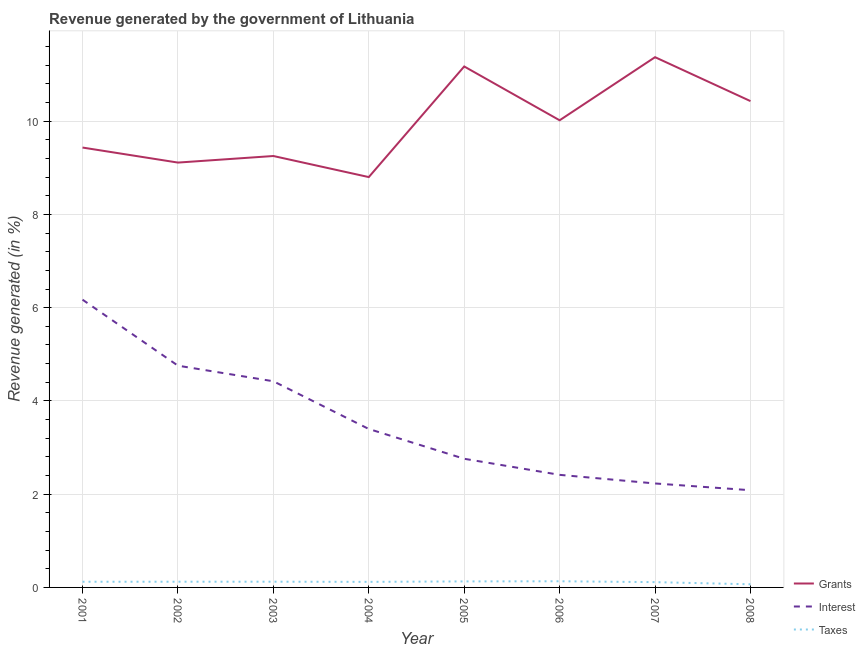Is the number of lines equal to the number of legend labels?
Give a very brief answer. Yes. What is the percentage of revenue generated by grants in 2003?
Provide a short and direct response. 9.25. Across all years, what is the maximum percentage of revenue generated by taxes?
Provide a short and direct response. 0.13. Across all years, what is the minimum percentage of revenue generated by grants?
Ensure brevity in your answer.  8.8. What is the total percentage of revenue generated by grants in the graph?
Offer a very short reply. 79.6. What is the difference between the percentage of revenue generated by grants in 2006 and that in 2008?
Offer a terse response. -0.41. What is the difference between the percentage of revenue generated by interest in 2006 and the percentage of revenue generated by taxes in 2001?
Offer a very short reply. 2.29. What is the average percentage of revenue generated by taxes per year?
Your answer should be very brief. 0.12. In the year 2002, what is the difference between the percentage of revenue generated by taxes and percentage of revenue generated by interest?
Provide a succinct answer. -4.63. What is the ratio of the percentage of revenue generated by grants in 2006 to that in 2007?
Give a very brief answer. 0.88. Is the percentage of revenue generated by taxes in 2003 less than that in 2004?
Your answer should be very brief. No. What is the difference between the highest and the second highest percentage of revenue generated by taxes?
Your response must be concise. 0. What is the difference between the highest and the lowest percentage of revenue generated by taxes?
Ensure brevity in your answer.  0.06. In how many years, is the percentage of revenue generated by grants greater than the average percentage of revenue generated by grants taken over all years?
Provide a succinct answer. 4. Is the sum of the percentage of revenue generated by grants in 2004 and 2005 greater than the maximum percentage of revenue generated by interest across all years?
Provide a short and direct response. Yes. Is it the case that in every year, the sum of the percentage of revenue generated by grants and percentage of revenue generated by interest is greater than the percentage of revenue generated by taxes?
Give a very brief answer. Yes. Is the percentage of revenue generated by interest strictly less than the percentage of revenue generated by grants over the years?
Your response must be concise. Yes. How many years are there in the graph?
Your answer should be compact. 8. What is the difference between two consecutive major ticks on the Y-axis?
Your answer should be very brief. 2. Are the values on the major ticks of Y-axis written in scientific E-notation?
Give a very brief answer. No. Does the graph contain any zero values?
Your answer should be compact. No. Where does the legend appear in the graph?
Provide a short and direct response. Bottom right. How many legend labels are there?
Give a very brief answer. 3. What is the title of the graph?
Your response must be concise. Revenue generated by the government of Lithuania. What is the label or title of the Y-axis?
Your answer should be very brief. Revenue generated (in %). What is the Revenue generated (in %) in Grants in 2001?
Ensure brevity in your answer.  9.44. What is the Revenue generated (in %) in Interest in 2001?
Ensure brevity in your answer.  6.17. What is the Revenue generated (in %) in Taxes in 2001?
Provide a succinct answer. 0.12. What is the Revenue generated (in %) in Grants in 2002?
Your response must be concise. 9.11. What is the Revenue generated (in %) of Interest in 2002?
Your answer should be compact. 4.76. What is the Revenue generated (in %) of Taxes in 2002?
Offer a terse response. 0.12. What is the Revenue generated (in %) in Grants in 2003?
Ensure brevity in your answer.  9.25. What is the Revenue generated (in %) of Interest in 2003?
Provide a short and direct response. 4.42. What is the Revenue generated (in %) of Taxes in 2003?
Your answer should be very brief. 0.12. What is the Revenue generated (in %) of Grants in 2004?
Offer a very short reply. 8.8. What is the Revenue generated (in %) of Interest in 2004?
Your answer should be compact. 3.4. What is the Revenue generated (in %) in Taxes in 2004?
Ensure brevity in your answer.  0.12. What is the Revenue generated (in %) of Grants in 2005?
Give a very brief answer. 11.17. What is the Revenue generated (in %) of Interest in 2005?
Provide a short and direct response. 2.76. What is the Revenue generated (in %) of Taxes in 2005?
Your response must be concise. 0.13. What is the Revenue generated (in %) in Grants in 2006?
Ensure brevity in your answer.  10.02. What is the Revenue generated (in %) in Interest in 2006?
Keep it short and to the point. 2.41. What is the Revenue generated (in %) of Taxes in 2006?
Offer a very short reply. 0.13. What is the Revenue generated (in %) in Grants in 2007?
Your answer should be very brief. 11.37. What is the Revenue generated (in %) of Interest in 2007?
Provide a succinct answer. 2.23. What is the Revenue generated (in %) of Taxes in 2007?
Ensure brevity in your answer.  0.11. What is the Revenue generated (in %) in Grants in 2008?
Your answer should be very brief. 10.43. What is the Revenue generated (in %) in Interest in 2008?
Give a very brief answer. 2.09. What is the Revenue generated (in %) of Taxes in 2008?
Offer a very short reply. 0.07. Across all years, what is the maximum Revenue generated (in %) in Grants?
Provide a short and direct response. 11.37. Across all years, what is the maximum Revenue generated (in %) of Interest?
Keep it short and to the point. 6.17. Across all years, what is the maximum Revenue generated (in %) in Taxes?
Provide a succinct answer. 0.13. Across all years, what is the minimum Revenue generated (in %) of Grants?
Offer a very short reply. 8.8. Across all years, what is the minimum Revenue generated (in %) in Interest?
Keep it short and to the point. 2.09. Across all years, what is the minimum Revenue generated (in %) of Taxes?
Give a very brief answer. 0.07. What is the total Revenue generated (in %) in Grants in the graph?
Provide a short and direct response. 79.6. What is the total Revenue generated (in %) in Interest in the graph?
Your answer should be compact. 28.24. What is the total Revenue generated (in %) in Taxes in the graph?
Your response must be concise. 0.93. What is the difference between the Revenue generated (in %) in Grants in 2001 and that in 2002?
Offer a very short reply. 0.32. What is the difference between the Revenue generated (in %) of Interest in 2001 and that in 2002?
Offer a very short reply. 1.42. What is the difference between the Revenue generated (in %) of Taxes in 2001 and that in 2002?
Your answer should be very brief. -0. What is the difference between the Revenue generated (in %) of Grants in 2001 and that in 2003?
Offer a terse response. 0.18. What is the difference between the Revenue generated (in %) in Interest in 2001 and that in 2003?
Provide a short and direct response. 1.75. What is the difference between the Revenue generated (in %) in Taxes in 2001 and that in 2003?
Your answer should be very brief. -0. What is the difference between the Revenue generated (in %) in Grants in 2001 and that in 2004?
Provide a succinct answer. 0.63. What is the difference between the Revenue generated (in %) of Interest in 2001 and that in 2004?
Offer a terse response. 2.77. What is the difference between the Revenue generated (in %) of Taxes in 2001 and that in 2004?
Offer a very short reply. 0. What is the difference between the Revenue generated (in %) of Grants in 2001 and that in 2005?
Keep it short and to the point. -1.74. What is the difference between the Revenue generated (in %) in Interest in 2001 and that in 2005?
Your response must be concise. 3.41. What is the difference between the Revenue generated (in %) of Taxes in 2001 and that in 2005?
Make the answer very short. -0.01. What is the difference between the Revenue generated (in %) in Grants in 2001 and that in 2006?
Your response must be concise. -0.58. What is the difference between the Revenue generated (in %) in Interest in 2001 and that in 2006?
Offer a very short reply. 3.76. What is the difference between the Revenue generated (in %) of Taxes in 2001 and that in 2006?
Your response must be concise. -0.01. What is the difference between the Revenue generated (in %) of Grants in 2001 and that in 2007?
Provide a succinct answer. -1.94. What is the difference between the Revenue generated (in %) of Interest in 2001 and that in 2007?
Keep it short and to the point. 3.94. What is the difference between the Revenue generated (in %) in Taxes in 2001 and that in 2007?
Keep it short and to the point. 0.01. What is the difference between the Revenue generated (in %) of Grants in 2001 and that in 2008?
Make the answer very short. -1. What is the difference between the Revenue generated (in %) of Interest in 2001 and that in 2008?
Make the answer very short. 4.09. What is the difference between the Revenue generated (in %) of Taxes in 2001 and that in 2008?
Keep it short and to the point. 0.05. What is the difference between the Revenue generated (in %) in Grants in 2002 and that in 2003?
Provide a short and direct response. -0.14. What is the difference between the Revenue generated (in %) in Interest in 2002 and that in 2003?
Make the answer very short. 0.33. What is the difference between the Revenue generated (in %) of Taxes in 2002 and that in 2003?
Provide a short and direct response. -0. What is the difference between the Revenue generated (in %) in Grants in 2002 and that in 2004?
Your response must be concise. 0.31. What is the difference between the Revenue generated (in %) in Interest in 2002 and that in 2004?
Your response must be concise. 1.36. What is the difference between the Revenue generated (in %) of Taxes in 2002 and that in 2004?
Your answer should be very brief. 0. What is the difference between the Revenue generated (in %) of Grants in 2002 and that in 2005?
Your answer should be compact. -2.06. What is the difference between the Revenue generated (in %) of Interest in 2002 and that in 2005?
Make the answer very short. 2. What is the difference between the Revenue generated (in %) of Taxes in 2002 and that in 2005?
Ensure brevity in your answer.  -0.01. What is the difference between the Revenue generated (in %) in Grants in 2002 and that in 2006?
Your response must be concise. -0.91. What is the difference between the Revenue generated (in %) in Interest in 2002 and that in 2006?
Provide a short and direct response. 2.34. What is the difference between the Revenue generated (in %) of Taxes in 2002 and that in 2006?
Your answer should be very brief. -0.01. What is the difference between the Revenue generated (in %) of Grants in 2002 and that in 2007?
Your answer should be very brief. -2.26. What is the difference between the Revenue generated (in %) of Interest in 2002 and that in 2007?
Offer a terse response. 2.53. What is the difference between the Revenue generated (in %) in Taxes in 2002 and that in 2007?
Keep it short and to the point. 0.01. What is the difference between the Revenue generated (in %) of Grants in 2002 and that in 2008?
Your answer should be very brief. -1.32. What is the difference between the Revenue generated (in %) in Interest in 2002 and that in 2008?
Keep it short and to the point. 2.67. What is the difference between the Revenue generated (in %) of Taxes in 2002 and that in 2008?
Offer a terse response. 0.06. What is the difference between the Revenue generated (in %) of Grants in 2003 and that in 2004?
Provide a succinct answer. 0.45. What is the difference between the Revenue generated (in %) in Interest in 2003 and that in 2004?
Your response must be concise. 1.02. What is the difference between the Revenue generated (in %) of Taxes in 2003 and that in 2004?
Make the answer very short. 0. What is the difference between the Revenue generated (in %) in Grants in 2003 and that in 2005?
Offer a terse response. -1.92. What is the difference between the Revenue generated (in %) of Interest in 2003 and that in 2005?
Your response must be concise. 1.66. What is the difference between the Revenue generated (in %) in Taxes in 2003 and that in 2005?
Offer a very short reply. -0.01. What is the difference between the Revenue generated (in %) of Grants in 2003 and that in 2006?
Keep it short and to the point. -0.77. What is the difference between the Revenue generated (in %) of Interest in 2003 and that in 2006?
Offer a very short reply. 2.01. What is the difference between the Revenue generated (in %) in Taxes in 2003 and that in 2006?
Your answer should be compact. -0.01. What is the difference between the Revenue generated (in %) in Grants in 2003 and that in 2007?
Provide a short and direct response. -2.12. What is the difference between the Revenue generated (in %) in Interest in 2003 and that in 2007?
Provide a short and direct response. 2.19. What is the difference between the Revenue generated (in %) of Taxes in 2003 and that in 2007?
Provide a succinct answer. 0.01. What is the difference between the Revenue generated (in %) in Grants in 2003 and that in 2008?
Offer a very short reply. -1.18. What is the difference between the Revenue generated (in %) in Interest in 2003 and that in 2008?
Give a very brief answer. 2.34. What is the difference between the Revenue generated (in %) in Taxes in 2003 and that in 2008?
Offer a terse response. 0.06. What is the difference between the Revenue generated (in %) in Grants in 2004 and that in 2005?
Ensure brevity in your answer.  -2.37. What is the difference between the Revenue generated (in %) in Interest in 2004 and that in 2005?
Provide a short and direct response. 0.64. What is the difference between the Revenue generated (in %) of Taxes in 2004 and that in 2005?
Offer a very short reply. -0.01. What is the difference between the Revenue generated (in %) in Grants in 2004 and that in 2006?
Provide a succinct answer. -1.22. What is the difference between the Revenue generated (in %) in Interest in 2004 and that in 2006?
Your answer should be very brief. 0.98. What is the difference between the Revenue generated (in %) of Taxes in 2004 and that in 2006?
Your answer should be very brief. -0.01. What is the difference between the Revenue generated (in %) in Grants in 2004 and that in 2007?
Offer a very short reply. -2.57. What is the difference between the Revenue generated (in %) in Interest in 2004 and that in 2007?
Provide a short and direct response. 1.17. What is the difference between the Revenue generated (in %) in Taxes in 2004 and that in 2007?
Give a very brief answer. 0.01. What is the difference between the Revenue generated (in %) in Grants in 2004 and that in 2008?
Your response must be concise. -1.63. What is the difference between the Revenue generated (in %) of Interest in 2004 and that in 2008?
Provide a succinct answer. 1.31. What is the difference between the Revenue generated (in %) of Taxes in 2004 and that in 2008?
Your response must be concise. 0.05. What is the difference between the Revenue generated (in %) in Grants in 2005 and that in 2006?
Give a very brief answer. 1.15. What is the difference between the Revenue generated (in %) in Interest in 2005 and that in 2006?
Provide a succinct answer. 0.34. What is the difference between the Revenue generated (in %) of Taxes in 2005 and that in 2006?
Keep it short and to the point. -0. What is the difference between the Revenue generated (in %) in Grants in 2005 and that in 2007?
Offer a very short reply. -0.2. What is the difference between the Revenue generated (in %) in Interest in 2005 and that in 2007?
Keep it short and to the point. 0.53. What is the difference between the Revenue generated (in %) of Taxes in 2005 and that in 2007?
Ensure brevity in your answer.  0.02. What is the difference between the Revenue generated (in %) in Grants in 2005 and that in 2008?
Your answer should be very brief. 0.74. What is the difference between the Revenue generated (in %) of Interest in 2005 and that in 2008?
Keep it short and to the point. 0.67. What is the difference between the Revenue generated (in %) in Taxes in 2005 and that in 2008?
Make the answer very short. 0.06. What is the difference between the Revenue generated (in %) of Grants in 2006 and that in 2007?
Offer a terse response. -1.35. What is the difference between the Revenue generated (in %) of Interest in 2006 and that in 2007?
Provide a succinct answer. 0.18. What is the difference between the Revenue generated (in %) in Taxes in 2006 and that in 2007?
Give a very brief answer. 0.02. What is the difference between the Revenue generated (in %) in Grants in 2006 and that in 2008?
Make the answer very short. -0.41. What is the difference between the Revenue generated (in %) of Interest in 2006 and that in 2008?
Keep it short and to the point. 0.33. What is the difference between the Revenue generated (in %) in Taxes in 2006 and that in 2008?
Your response must be concise. 0.06. What is the difference between the Revenue generated (in %) in Grants in 2007 and that in 2008?
Keep it short and to the point. 0.94. What is the difference between the Revenue generated (in %) of Interest in 2007 and that in 2008?
Your answer should be very brief. 0.14. What is the difference between the Revenue generated (in %) in Taxes in 2007 and that in 2008?
Provide a succinct answer. 0.05. What is the difference between the Revenue generated (in %) in Grants in 2001 and the Revenue generated (in %) in Interest in 2002?
Give a very brief answer. 4.68. What is the difference between the Revenue generated (in %) in Grants in 2001 and the Revenue generated (in %) in Taxes in 2002?
Your answer should be very brief. 9.31. What is the difference between the Revenue generated (in %) in Interest in 2001 and the Revenue generated (in %) in Taxes in 2002?
Make the answer very short. 6.05. What is the difference between the Revenue generated (in %) of Grants in 2001 and the Revenue generated (in %) of Interest in 2003?
Your answer should be compact. 5.01. What is the difference between the Revenue generated (in %) in Grants in 2001 and the Revenue generated (in %) in Taxes in 2003?
Make the answer very short. 9.31. What is the difference between the Revenue generated (in %) of Interest in 2001 and the Revenue generated (in %) of Taxes in 2003?
Ensure brevity in your answer.  6.05. What is the difference between the Revenue generated (in %) in Grants in 2001 and the Revenue generated (in %) in Interest in 2004?
Keep it short and to the point. 6.04. What is the difference between the Revenue generated (in %) of Grants in 2001 and the Revenue generated (in %) of Taxes in 2004?
Provide a succinct answer. 9.32. What is the difference between the Revenue generated (in %) of Interest in 2001 and the Revenue generated (in %) of Taxes in 2004?
Ensure brevity in your answer.  6.05. What is the difference between the Revenue generated (in %) of Grants in 2001 and the Revenue generated (in %) of Interest in 2005?
Ensure brevity in your answer.  6.68. What is the difference between the Revenue generated (in %) of Grants in 2001 and the Revenue generated (in %) of Taxes in 2005?
Make the answer very short. 9.31. What is the difference between the Revenue generated (in %) of Interest in 2001 and the Revenue generated (in %) of Taxes in 2005?
Keep it short and to the point. 6.04. What is the difference between the Revenue generated (in %) of Grants in 2001 and the Revenue generated (in %) of Interest in 2006?
Your answer should be very brief. 7.02. What is the difference between the Revenue generated (in %) in Grants in 2001 and the Revenue generated (in %) in Taxes in 2006?
Make the answer very short. 9.3. What is the difference between the Revenue generated (in %) of Interest in 2001 and the Revenue generated (in %) of Taxes in 2006?
Give a very brief answer. 6.04. What is the difference between the Revenue generated (in %) of Grants in 2001 and the Revenue generated (in %) of Interest in 2007?
Provide a succinct answer. 7.21. What is the difference between the Revenue generated (in %) in Grants in 2001 and the Revenue generated (in %) in Taxes in 2007?
Provide a short and direct response. 9.32. What is the difference between the Revenue generated (in %) in Interest in 2001 and the Revenue generated (in %) in Taxes in 2007?
Keep it short and to the point. 6.06. What is the difference between the Revenue generated (in %) in Grants in 2001 and the Revenue generated (in %) in Interest in 2008?
Your response must be concise. 7.35. What is the difference between the Revenue generated (in %) of Grants in 2001 and the Revenue generated (in %) of Taxes in 2008?
Your answer should be very brief. 9.37. What is the difference between the Revenue generated (in %) in Interest in 2001 and the Revenue generated (in %) in Taxes in 2008?
Your response must be concise. 6.1. What is the difference between the Revenue generated (in %) in Grants in 2002 and the Revenue generated (in %) in Interest in 2003?
Offer a terse response. 4.69. What is the difference between the Revenue generated (in %) in Grants in 2002 and the Revenue generated (in %) in Taxes in 2003?
Give a very brief answer. 8.99. What is the difference between the Revenue generated (in %) in Interest in 2002 and the Revenue generated (in %) in Taxes in 2003?
Offer a very short reply. 4.63. What is the difference between the Revenue generated (in %) of Grants in 2002 and the Revenue generated (in %) of Interest in 2004?
Provide a short and direct response. 5.71. What is the difference between the Revenue generated (in %) in Grants in 2002 and the Revenue generated (in %) in Taxes in 2004?
Ensure brevity in your answer.  8.99. What is the difference between the Revenue generated (in %) of Interest in 2002 and the Revenue generated (in %) of Taxes in 2004?
Provide a succinct answer. 4.64. What is the difference between the Revenue generated (in %) in Grants in 2002 and the Revenue generated (in %) in Interest in 2005?
Provide a short and direct response. 6.35. What is the difference between the Revenue generated (in %) in Grants in 2002 and the Revenue generated (in %) in Taxes in 2005?
Ensure brevity in your answer.  8.98. What is the difference between the Revenue generated (in %) of Interest in 2002 and the Revenue generated (in %) of Taxes in 2005?
Your response must be concise. 4.63. What is the difference between the Revenue generated (in %) in Grants in 2002 and the Revenue generated (in %) in Interest in 2006?
Offer a terse response. 6.7. What is the difference between the Revenue generated (in %) in Grants in 2002 and the Revenue generated (in %) in Taxes in 2006?
Give a very brief answer. 8.98. What is the difference between the Revenue generated (in %) in Interest in 2002 and the Revenue generated (in %) in Taxes in 2006?
Offer a very short reply. 4.62. What is the difference between the Revenue generated (in %) in Grants in 2002 and the Revenue generated (in %) in Interest in 2007?
Provide a short and direct response. 6.88. What is the difference between the Revenue generated (in %) of Grants in 2002 and the Revenue generated (in %) of Taxes in 2007?
Make the answer very short. 9. What is the difference between the Revenue generated (in %) of Interest in 2002 and the Revenue generated (in %) of Taxes in 2007?
Provide a succinct answer. 4.64. What is the difference between the Revenue generated (in %) of Grants in 2002 and the Revenue generated (in %) of Interest in 2008?
Offer a very short reply. 7.03. What is the difference between the Revenue generated (in %) of Grants in 2002 and the Revenue generated (in %) of Taxes in 2008?
Offer a terse response. 9.05. What is the difference between the Revenue generated (in %) of Interest in 2002 and the Revenue generated (in %) of Taxes in 2008?
Make the answer very short. 4.69. What is the difference between the Revenue generated (in %) in Grants in 2003 and the Revenue generated (in %) in Interest in 2004?
Provide a short and direct response. 5.86. What is the difference between the Revenue generated (in %) in Grants in 2003 and the Revenue generated (in %) in Taxes in 2004?
Provide a short and direct response. 9.13. What is the difference between the Revenue generated (in %) of Interest in 2003 and the Revenue generated (in %) of Taxes in 2004?
Your answer should be compact. 4.3. What is the difference between the Revenue generated (in %) in Grants in 2003 and the Revenue generated (in %) in Interest in 2005?
Your answer should be very brief. 6.49. What is the difference between the Revenue generated (in %) in Grants in 2003 and the Revenue generated (in %) in Taxes in 2005?
Your response must be concise. 9.12. What is the difference between the Revenue generated (in %) in Interest in 2003 and the Revenue generated (in %) in Taxes in 2005?
Your response must be concise. 4.29. What is the difference between the Revenue generated (in %) of Grants in 2003 and the Revenue generated (in %) of Interest in 2006?
Your answer should be very brief. 6.84. What is the difference between the Revenue generated (in %) of Grants in 2003 and the Revenue generated (in %) of Taxes in 2006?
Offer a terse response. 9.12. What is the difference between the Revenue generated (in %) of Interest in 2003 and the Revenue generated (in %) of Taxes in 2006?
Ensure brevity in your answer.  4.29. What is the difference between the Revenue generated (in %) in Grants in 2003 and the Revenue generated (in %) in Interest in 2007?
Your answer should be compact. 7.02. What is the difference between the Revenue generated (in %) in Grants in 2003 and the Revenue generated (in %) in Taxes in 2007?
Offer a very short reply. 9.14. What is the difference between the Revenue generated (in %) of Interest in 2003 and the Revenue generated (in %) of Taxes in 2007?
Your response must be concise. 4.31. What is the difference between the Revenue generated (in %) in Grants in 2003 and the Revenue generated (in %) in Interest in 2008?
Your answer should be very brief. 7.17. What is the difference between the Revenue generated (in %) in Grants in 2003 and the Revenue generated (in %) in Taxes in 2008?
Provide a short and direct response. 9.19. What is the difference between the Revenue generated (in %) of Interest in 2003 and the Revenue generated (in %) of Taxes in 2008?
Your response must be concise. 4.35. What is the difference between the Revenue generated (in %) of Grants in 2004 and the Revenue generated (in %) of Interest in 2005?
Keep it short and to the point. 6.04. What is the difference between the Revenue generated (in %) of Grants in 2004 and the Revenue generated (in %) of Taxes in 2005?
Your answer should be compact. 8.67. What is the difference between the Revenue generated (in %) in Interest in 2004 and the Revenue generated (in %) in Taxes in 2005?
Your answer should be compact. 3.27. What is the difference between the Revenue generated (in %) of Grants in 2004 and the Revenue generated (in %) of Interest in 2006?
Your response must be concise. 6.39. What is the difference between the Revenue generated (in %) of Grants in 2004 and the Revenue generated (in %) of Taxes in 2006?
Your response must be concise. 8.67. What is the difference between the Revenue generated (in %) in Interest in 2004 and the Revenue generated (in %) in Taxes in 2006?
Your answer should be compact. 3.27. What is the difference between the Revenue generated (in %) of Grants in 2004 and the Revenue generated (in %) of Interest in 2007?
Ensure brevity in your answer.  6.57. What is the difference between the Revenue generated (in %) in Grants in 2004 and the Revenue generated (in %) in Taxes in 2007?
Make the answer very short. 8.69. What is the difference between the Revenue generated (in %) of Interest in 2004 and the Revenue generated (in %) of Taxes in 2007?
Ensure brevity in your answer.  3.29. What is the difference between the Revenue generated (in %) of Grants in 2004 and the Revenue generated (in %) of Interest in 2008?
Provide a short and direct response. 6.72. What is the difference between the Revenue generated (in %) in Grants in 2004 and the Revenue generated (in %) in Taxes in 2008?
Provide a short and direct response. 8.73. What is the difference between the Revenue generated (in %) in Interest in 2004 and the Revenue generated (in %) in Taxes in 2008?
Provide a short and direct response. 3.33. What is the difference between the Revenue generated (in %) in Grants in 2005 and the Revenue generated (in %) in Interest in 2006?
Keep it short and to the point. 8.76. What is the difference between the Revenue generated (in %) of Grants in 2005 and the Revenue generated (in %) of Taxes in 2006?
Your answer should be compact. 11.04. What is the difference between the Revenue generated (in %) in Interest in 2005 and the Revenue generated (in %) in Taxes in 2006?
Give a very brief answer. 2.63. What is the difference between the Revenue generated (in %) in Grants in 2005 and the Revenue generated (in %) in Interest in 2007?
Provide a short and direct response. 8.94. What is the difference between the Revenue generated (in %) in Grants in 2005 and the Revenue generated (in %) in Taxes in 2007?
Provide a succinct answer. 11.06. What is the difference between the Revenue generated (in %) of Interest in 2005 and the Revenue generated (in %) of Taxes in 2007?
Keep it short and to the point. 2.65. What is the difference between the Revenue generated (in %) in Grants in 2005 and the Revenue generated (in %) in Interest in 2008?
Your response must be concise. 9.09. What is the difference between the Revenue generated (in %) in Grants in 2005 and the Revenue generated (in %) in Taxes in 2008?
Offer a very short reply. 11.11. What is the difference between the Revenue generated (in %) in Interest in 2005 and the Revenue generated (in %) in Taxes in 2008?
Offer a very short reply. 2.69. What is the difference between the Revenue generated (in %) in Grants in 2006 and the Revenue generated (in %) in Interest in 2007?
Your answer should be very brief. 7.79. What is the difference between the Revenue generated (in %) in Grants in 2006 and the Revenue generated (in %) in Taxes in 2007?
Offer a terse response. 9.91. What is the difference between the Revenue generated (in %) of Interest in 2006 and the Revenue generated (in %) of Taxes in 2007?
Provide a short and direct response. 2.3. What is the difference between the Revenue generated (in %) of Grants in 2006 and the Revenue generated (in %) of Interest in 2008?
Your answer should be compact. 7.93. What is the difference between the Revenue generated (in %) of Grants in 2006 and the Revenue generated (in %) of Taxes in 2008?
Give a very brief answer. 9.95. What is the difference between the Revenue generated (in %) in Interest in 2006 and the Revenue generated (in %) in Taxes in 2008?
Offer a terse response. 2.35. What is the difference between the Revenue generated (in %) in Grants in 2007 and the Revenue generated (in %) in Interest in 2008?
Your answer should be very brief. 9.29. What is the difference between the Revenue generated (in %) in Grants in 2007 and the Revenue generated (in %) in Taxes in 2008?
Provide a short and direct response. 11.31. What is the difference between the Revenue generated (in %) in Interest in 2007 and the Revenue generated (in %) in Taxes in 2008?
Ensure brevity in your answer.  2.16. What is the average Revenue generated (in %) of Grants per year?
Your answer should be compact. 9.95. What is the average Revenue generated (in %) of Interest per year?
Your answer should be compact. 3.53. What is the average Revenue generated (in %) in Taxes per year?
Give a very brief answer. 0.12. In the year 2001, what is the difference between the Revenue generated (in %) of Grants and Revenue generated (in %) of Interest?
Your response must be concise. 3.26. In the year 2001, what is the difference between the Revenue generated (in %) of Grants and Revenue generated (in %) of Taxes?
Your response must be concise. 9.31. In the year 2001, what is the difference between the Revenue generated (in %) of Interest and Revenue generated (in %) of Taxes?
Give a very brief answer. 6.05. In the year 2002, what is the difference between the Revenue generated (in %) of Grants and Revenue generated (in %) of Interest?
Your response must be concise. 4.36. In the year 2002, what is the difference between the Revenue generated (in %) in Grants and Revenue generated (in %) in Taxes?
Your answer should be compact. 8.99. In the year 2002, what is the difference between the Revenue generated (in %) of Interest and Revenue generated (in %) of Taxes?
Keep it short and to the point. 4.63. In the year 2003, what is the difference between the Revenue generated (in %) of Grants and Revenue generated (in %) of Interest?
Your response must be concise. 4.83. In the year 2003, what is the difference between the Revenue generated (in %) of Grants and Revenue generated (in %) of Taxes?
Your response must be concise. 9.13. In the year 2003, what is the difference between the Revenue generated (in %) in Interest and Revenue generated (in %) in Taxes?
Your answer should be compact. 4.3. In the year 2004, what is the difference between the Revenue generated (in %) of Grants and Revenue generated (in %) of Interest?
Offer a very short reply. 5.4. In the year 2004, what is the difference between the Revenue generated (in %) in Grants and Revenue generated (in %) in Taxes?
Offer a terse response. 8.68. In the year 2004, what is the difference between the Revenue generated (in %) of Interest and Revenue generated (in %) of Taxes?
Offer a very short reply. 3.28. In the year 2005, what is the difference between the Revenue generated (in %) in Grants and Revenue generated (in %) in Interest?
Offer a very short reply. 8.41. In the year 2005, what is the difference between the Revenue generated (in %) of Grants and Revenue generated (in %) of Taxes?
Give a very brief answer. 11.05. In the year 2005, what is the difference between the Revenue generated (in %) in Interest and Revenue generated (in %) in Taxes?
Offer a terse response. 2.63. In the year 2006, what is the difference between the Revenue generated (in %) in Grants and Revenue generated (in %) in Interest?
Offer a very short reply. 7.61. In the year 2006, what is the difference between the Revenue generated (in %) of Grants and Revenue generated (in %) of Taxes?
Make the answer very short. 9.89. In the year 2006, what is the difference between the Revenue generated (in %) of Interest and Revenue generated (in %) of Taxes?
Ensure brevity in your answer.  2.28. In the year 2007, what is the difference between the Revenue generated (in %) in Grants and Revenue generated (in %) in Interest?
Give a very brief answer. 9.14. In the year 2007, what is the difference between the Revenue generated (in %) in Grants and Revenue generated (in %) in Taxes?
Make the answer very short. 11.26. In the year 2007, what is the difference between the Revenue generated (in %) in Interest and Revenue generated (in %) in Taxes?
Keep it short and to the point. 2.12. In the year 2008, what is the difference between the Revenue generated (in %) of Grants and Revenue generated (in %) of Interest?
Give a very brief answer. 8.35. In the year 2008, what is the difference between the Revenue generated (in %) of Grants and Revenue generated (in %) of Taxes?
Your response must be concise. 10.36. In the year 2008, what is the difference between the Revenue generated (in %) of Interest and Revenue generated (in %) of Taxes?
Offer a terse response. 2.02. What is the ratio of the Revenue generated (in %) of Grants in 2001 to that in 2002?
Give a very brief answer. 1.04. What is the ratio of the Revenue generated (in %) of Interest in 2001 to that in 2002?
Your response must be concise. 1.3. What is the ratio of the Revenue generated (in %) in Grants in 2001 to that in 2003?
Offer a terse response. 1.02. What is the ratio of the Revenue generated (in %) of Interest in 2001 to that in 2003?
Ensure brevity in your answer.  1.4. What is the ratio of the Revenue generated (in %) of Taxes in 2001 to that in 2003?
Offer a terse response. 0.99. What is the ratio of the Revenue generated (in %) in Grants in 2001 to that in 2004?
Provide a succinct answer. 1.07. What is the ratio of the Revenue generated (in %) in Interest in 2001 to that in 2004?
Keep it short and to the point. 1.82. What is the ratio of the Revenue generated (in %) in Taxes in 2001 to that in 2004?
Provide a succinct answer. 1.02. What is the ratio of the Revenue generated (in %) in Grants in 2001 to that in 2005?
Make the answer very short. 0.84. What is the ratio of the Revenue generated (in %) in Interest in 2001 to that in 2005?
Provide a short and direct response. 2.24. What is the ratio of the Revenue generated (in %) of Taxes in 2001 to that in 2005?
Ensure brevity in your answer.  0.94. What is the ratio of the Revenue generated (in %) in Grants in 2001 to that in 2006?
Your answer should be very brief. 0.94. What is the ratio of the Revenue generated (in %) in Interest in 2001 to that in 2006?
Keep it short and to the point. 2.56. What is the ratio of the Revenue generated (in %) of Taxes in 2001 to that in 2006?
Ensure brevity in your answer.  0.92. What is the ratio of the Revenue generated (in %) of Grants in 2001 to that in 2007?
Offer a very short reply. 0.83. What is the ratio of the Revenue generated (in %) of Interest in 2001 to that in 2007?
Offer a very short reply. 2.77. What is the ratio of the Revenue generated (in %) in Taxes in 2001 to that in 2007?
Make the answer very short. 1.07. What is the ratio of the Revenue generated (in %) in Grants in 2001 to that in 2008?
Provide a succinct answer. 0.9. What is the ratio of the Revenue generated (in %) in Interest in 2001 to that in 2008?
Your answer should be very brief. 2.96. What is the ratio of the Revenue generated (in %) of Taxes in 2001 to that in 2008?
Keep it short and to the point. 1.81. What is the ratio of the Revenue generated (in %) in Interest in 2002 to that in 2003?
Ensure brevity in your answer.  1.08. What is the ratio of the Revenue generated (in %) of Grants in 2002 to that in 2004?
Ensure brevity in your answer.  1.04. What is the ratio of the Revenue generated (in %) in Interest in 2002 to that in 2004?
Offer a terse response. 1.4. What is the ratio of the Revenue generated (in %) of Taxes in 2002 to that in 2004?
Give a very brief answer. 1.03. What is the ratio of the Revenue generated (in %) in Grants in 2002 to that in 2005?
Provide a short and direct response. 0.82. What is the ratio of the Revenue generated (in %) of Interest in 2002 to that in 2005?
Your answer should be compact. 1.72. What is the ratio of the Revenue generated (in %) of Taxes in 2002 to that in 2005?
Offer a very short reply. 0.95. What is the ratio of the Revenue generated (in %) in Grants in 2002 to that in 2006?
Your answer should be very brief. 0.91. What is the ratio of the Revenue generated (in %) in Interest in 2002 to that in 2006?
Give a very brief answer. 1.97. What is the ratio of the Revenue generated (in %) of Taxes in 2002 to that in 2006?
Provide a succinct answer. 0.93. What is the ratio of the Revenue generated (in %) in Grants in 2002 to that in 2007?
Provide a succinct answer. 0.8. What is the ratio of the Revenue generated (in %) in Interest in 2002 to that in 2007?
Ensure brevity in your answer.  2.13. What is the ratio of the Revenue generated (in %) in Taxes in 2002 to that in 2007?
Make the answer very short. 1.08. What is the ratio of the Revenue generated (in %) of Grants in 2002 to that in 2008?
Offer a very short reply. 0.87. What is the ratio of the Revenue generated (in %) of Interest in 2002 to that in 2008?
Make the answer very short. 2.28. What is the ratio of the Revenue generated (in %) of Taxes in 2002 to that in 2008?
Ensure brevity in your answer.  1.82. What is the ratio of the Revenue generated (in %) in Grants in 2003 to that in 2004?
Ensure brevity in your answer.  1.05. What is the ratio of the Revenue generated (in %) of Interest in 2003 to that in 2004?
Keep it short and to the point. 1.3. What is the ratio of the Revenue generated (in %) in Taxes in 2003 to that in 2004?
Your response must be concise. 1.03. What is the ratio of the Revenue generated (in %) of Grants in 2003 to that in 2005?
Make the answer very short. 0.83. What is the ratio of the Revenue generated (in %) in Interest in 2003 to that in 2005?
Keep it short and to the point. 1.6. What is the ratio of the Revenue generated (in %) of Taxes in 2003 to that in 2005?
Keep it short and to the point. 0.95. What is the ratio of the Revenue generated (in %) of Grants in 2003 to that in 2006?
Keep it short and to the point. 0.92. What is the ratio of the Revenue generated (in %) in Interest in 2003 to that in 2006?
Your answer should be very brief. 1.83. What is the ratio of the Revenue generated (in %) of Taxes in 2003 to that in 2006?
Provide a succinct answer. 0.93. What is the ratio of the Revenue generated (in %) in Grants in 2003 to that in 2007?
Your answer should be compact. 0.81. What is the ratio of the Revenue generated (in %) of Interest in 2003 to that in 2007?
Offer a very short reply. 1.98. What is the ratio of the Revenue generated (in %) of Taxes in 2003 to that in 2007?
Make the answer very short. 1.08. What is the ratio of the Revenue generated (in %) in Grants in 2003 to that in 2008?
Keep it short and to the point. 0.89. What is the ratio of the Revenue generated (in %) in Interest in 2003 to that in 2008?
Make the answer very short. 2.12. What is the ratio of the Revenue generated (in %) of Taxes in 2003 to that in 2008?
Your response must be concise. 1.82. What is the ratio of the Revenue generated (in %) of Grants in 2004 to that in 2005?
Offer a very short reply. 0.79. What is the ratio of the Revenue generated (in %) in Interest in 2004 to that in 2005?
Provide a succinct answer. 1.23. What is the ratio of the Revenue generated (in %) in Taxes in 2004 to that in 2005?
Offer a very short reply. 0.93. What is the ratio of the Revenue generated (in %) of Grants in 2004 to that in 2006?
Provide a succinct answer. 0.88. What is the ratio of the Revenue generated (in %) in Interest in 2004 to that in 2006?
Your answer should be very brief. 1.41. What is the ratio of the Revenue generated (in %) in Taxes in 2004 to that in 2006?
Offer a terse response. 0.9. What is the ratio of the Revenue generated (in %) in Grants in 2004 to that in 2007?
Your response must be concise. 0.77. What is the ratio of the Revenue generated (in %) in Interest in 2004 to that in 2007?
Your answer should be very brief. 1.52. What is the ratio of the Revenue generated (in %) of Taxes in 2004 to that in 2007?
Provide a succinct answer. 1.05. What is the ratio of the Revenue generated (in %) of Grants in 2004 to that in 2008?
Give a very brief answer. 0.84. What is the ratio of the Revenue generated (in %) of Interest in 2004 to that in 2008?
Make the answer very short. 1.63. What is the ratio of the Revenue generated (in %) in Taxes in 2004 to that in 2008?
Provide a succinct answer. 1.77. What is the ratio of the Revenue generated (in %) of Grants in 2005 to that in 2006?
Your answer should be compact. 1.12. What is the ratio of the Revenue generated (in %) of Interest in 2005 to that in 2006?
Ensure brevity in your answer.  1.14. What is the ratio of the Revenue generated (in %) of Taxes in 2005 to that in 2006?
Offer a very short reply. 0.98. What is the ratio of the Revenue generated (in %) in Grants in 2005 to that in 2007?
Provide a short and direct response. 0.98. What is the ratio of the Revenue generated (in %) in Interest in 2005 to that in 2007?
Keep it short and to the point. 1.24. What is the ratio of the Revenue generated (in %) in Taxes in 2005 to that in 2007?
Offer a terse response. 1.14. What is the ratio of the Revenue generated (in %) of Grants in 2005 to that in 2008?
Your answer should be very brief. 1.07. What is the ratio of the Revenue generated (in %) of Interest in 2005 to that in 2008?
Offer a very short reply. 1.32. What is the ratio of the Revenue generated (in %) of Taxes in 2005 to that in 2008?
Your response must be concise. 1.91. What is the ratio of the Revenue generated (in %) of Grants in 2006 to that in 2007?
Your answer should be compact. 0.88. What is the ratio of the Revenue generated (in %) in Interest in 2006 to that in 2007?
Ensure brevity in your answer.  1.08. What is the ratio of the Revenue generated (in %) in Taxes in 2006 to that in 2007?
Your answer should be very brief. 1.16. What is the ratio of the Revenue generated (in %) in Grants in 2006 to that in 2008?
Your answer should be compact. 0.96. What is the ratio of the Revenue generated (in %) in Interest in 2006 to that in 2008?
Provide a succinct answer. 1.16. What is the ratio of the Revenue generated (in %) in Taxes in 2006 to that in 2008?
Provide a short and direct response. 1.96. What is the ratio of the Revenue generated (in %) of Grants in 2007 to that in 2008?
Offer a terse response. 1.09. What is the ratio of the Revenue generated (in %) of Interest in 2007 to that in 2008?
Your response must be concise. 1.07. What is the ratio of the Revenue generated (in %) in Taxes in 2007 to that in 2008?
Ensure brevity in your answer.  1.68. What is the difference between the highest and the second highest Revenue generated (in %) in Grants?
Offer a terse response. 0.2. What is the difference between the highest and the second highest Revenue generated (in %) of Interest?
Make the answer very short. 1.42. What is the difference between the highest and the second highest Revenue generated (in %) of Taxes?
Your response must be concise. 0. What is the difference between the highest and the lowest Revenue generated (in %) of Grants?
Provide a succinct answer. 2.57. What is the difference between the highest and the lowest Revenue generated (in %) of Interest?
Your answer should be compact. 4.09. What is the difference between the highest and the lowest Revenue generated (in %) in Taxes?
Your response must be concise. 0.06. 